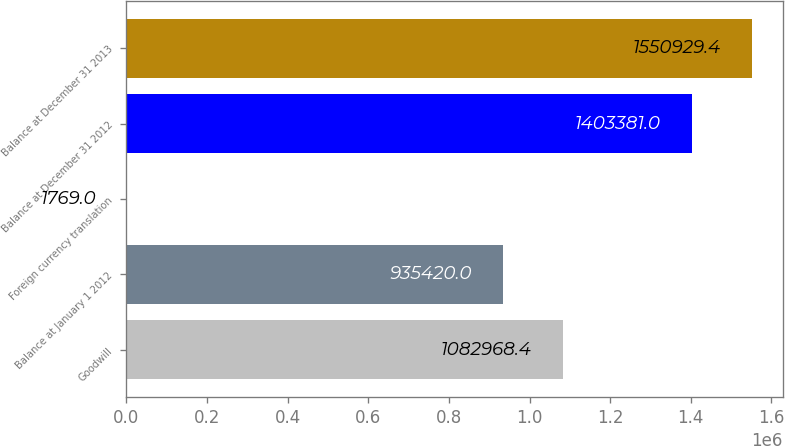Convert chart. <chart><loc_0><loc_0><loc_500><loc_500><bar_chart><fcel>Goodwill<fcel>Balance at January 1 2012<fcel>Foreign currency translation<fcel>Balance at December 31 2012<fcel>Balance at December 31 2013<nl><fcel>1.08297e+06<fcel>935420<fcel>1769<fcel>1.40338e+06<fcel>1.55093e+06<nl></chart> 